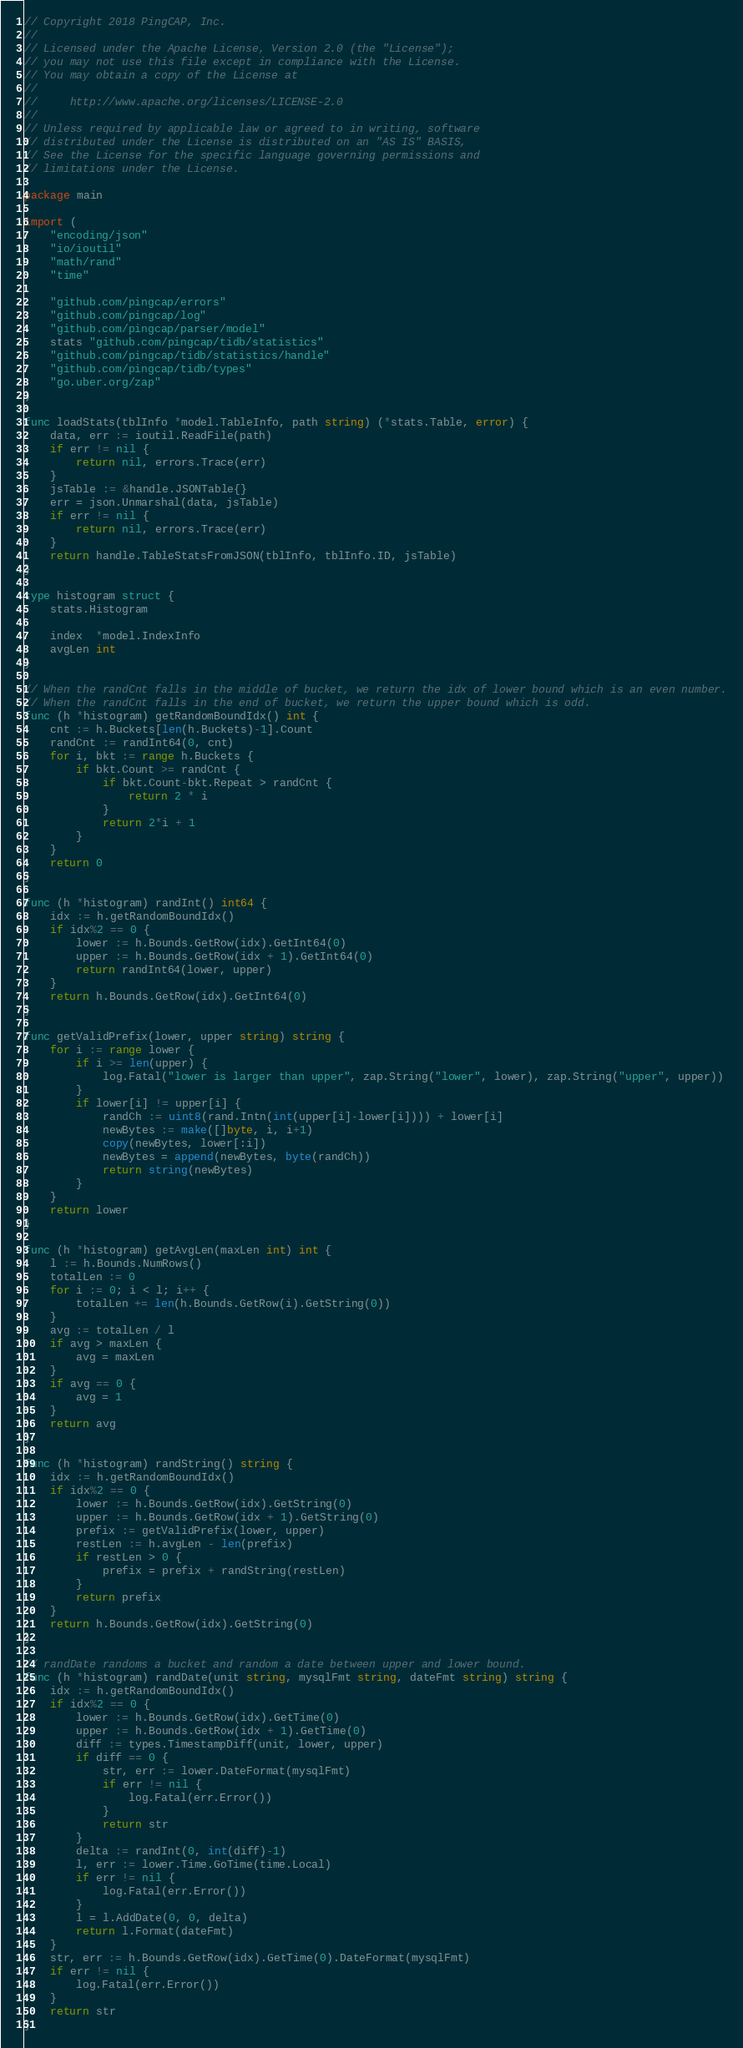<code> <loc_0><loc_0><loc_500><loc_500><_Go_>// Copyright 2018 PingCAP, Inc.
//
// Licensed under the Apache License, Version 2.0 (the "License");
// you may not use this file except in compliance with the License.
// You may obtain a copy of the License at
//
//     http://www.apache.org/licenses/LICENSE-2.0
//
// Unless required by applicable law or agreed to in writing, software
// distributed under the License is distributed on an "AS IS" BASIS,
// See the License for the specific language governing permissions and
// limitations under the License.

package main

import (
	"encoding/json"
	"io/ioutil"
	"math/rand"
	"time"

	"github.com/pingcap/errors"
	"github.com/pingcap/log"
	"github.com/pingcap/parser/model"
	stats "github.com/pingcap/tidb/statistics"
	"github.com/pingcap/tidb/statistics/handle"
	"github.com/pingcap/tidb/types"
	"go.uber.org/zap"
)

func loadStats(tblInfo *model.TableInfo, path string) (*stats.Table, error) {
	data, err := ioutil.ReadFile(path)
	if err != nil {
		return nil, errors.Trace(err)
	}
	jsTable := &handle.JSONTable{}
	err = json.Unmarshal(data, jsTable)
	if err != nil {
		return nil, errors.Trace(err)
	}
	return handle.TableStatsFromJSON(tblInfo, tblInfo.ID, jsTable)
}

type histogram struct {
	stats.Histogram

	index  *model.IndexInfo
	avgLen int
}

// When the randCnt falls in the middle of bucket, we return the idx of lower bound which is an even number.
// When the randCnt falls in the end of bucket, we return the upper bound which is odd.
func (h *histogram) getRandomBoundIdx() int {
	cnt := h.Buckets[len(h.Buckets)-1].Count
	randCnt := randInt64(0, cnt)
	for i, bkt := range h.Buckets {
		if bkt.Count >= randCnt {
			if bkt.Count-bkt.Repeat > randCnt {
				return 2 * i
			}
			return 2*i + 1
		}
	}
	return 0
}

func (h *histogram) randInt() int64 {
	idx := h.getRandomBoundIdx()
	if idx%2 == 0 {
		lower := h.Bounds.GetRow(idx).GetInt64(0)
		upper := h.Bounds.GetRow(idx + 1).GetInt64(0)
		return randInt64(lower, upper)
	}
	return h.Bounds.GetRow(idx).GetInt64(0)
}

func getValidPrefix(lower, upper string) string {
	for i := range lower {
		if i >= len(upper) {
			log.Fatal("lower is larger than upper", zap.String("lower", lower), zap.String("upper", upper))
		}
		if lower[i] != upper[i] {
			randCh := uint8(rand.Intn(int(upper[i]-lower[i]))) + lower[i]
			newBytes := make([]byte, i, i+1)
			copy(newBytes, lower[:i])
			newBytes = append(newBytes, byte(randCh))
			return string(newBytes)
		}
	}
	return lower
}

func (h *histogram) getAvgLen(maxLen int) int {
	l := h.Bounds.NumRows()
	totalLen := 0
	for i := 0; i < l; i++ {
		totalLen += len(h.Bounds.GetRow(i).GetString(0))
	}
	avg := totalLen / l
	if avg > maxLen {
		avg = maxLen
	}
	if avg == 0 {
		avg = 1
	}
	return avg
}

func (h *histogram) randString() string {
	idx := h.getRandomBoundIdx()
	if idx%2 == 0 {
		lower := h.Bounds.GetRow(idx).GetString(0)
		upper := h.Bounds.GetRow(idx + 1).GetString(0)
		prefix := getValidPrefix(lower, upper)
		restLen := h.avgLen - len(prefix)
		if restLen > 0 {
			prefix = prefix + randString(restLen)
		}
		return prefix
	}
	return h.Bounds.GetRow(idx).GetString(0)
}

// randDate randoms a bucket and random a date between upper and lower bound.
func (h *histogram) randDate(unit string, mysqlFmt string, dateFmt string) string {
	idx := h.getRandomBoundIdx()
	if idx%2 == 0 {
		lower := h.Bounds.GetRow(idx).GetTime(0)
		upper := h.Bounds.GetRow(idx + 1).GetTime(0)
		diff := types.TimestampDiff(unit, lower, upper)
		if diff == 0 {
			str, err := lower.DateFormat(mysqlFmt)
			if err != nil {
				log.Fatal(err.Error())
			}
			return str
		}
		delta := randInt(0, int(diff)-1)
		l, err := lower.Time.GoTime(time.Local)
		if err != nil {
			log.Fatal(err.Error())
		}
		l = l.AddDate(0, 0, delta)
		return l.Format(dateFmt)
	}
	str, err := h.Bounds.GetRow(idx).GetTime(0).DateFormat(mysqlFmt)
	if err != nil {
		log.Fatal(err.Error())
	}
	return str
}
</code> 